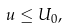Convert formula to latex. <formula><loc_0><loc_0><loc_500><loc_500>u \leq U _ { 0 } ,</formula> 